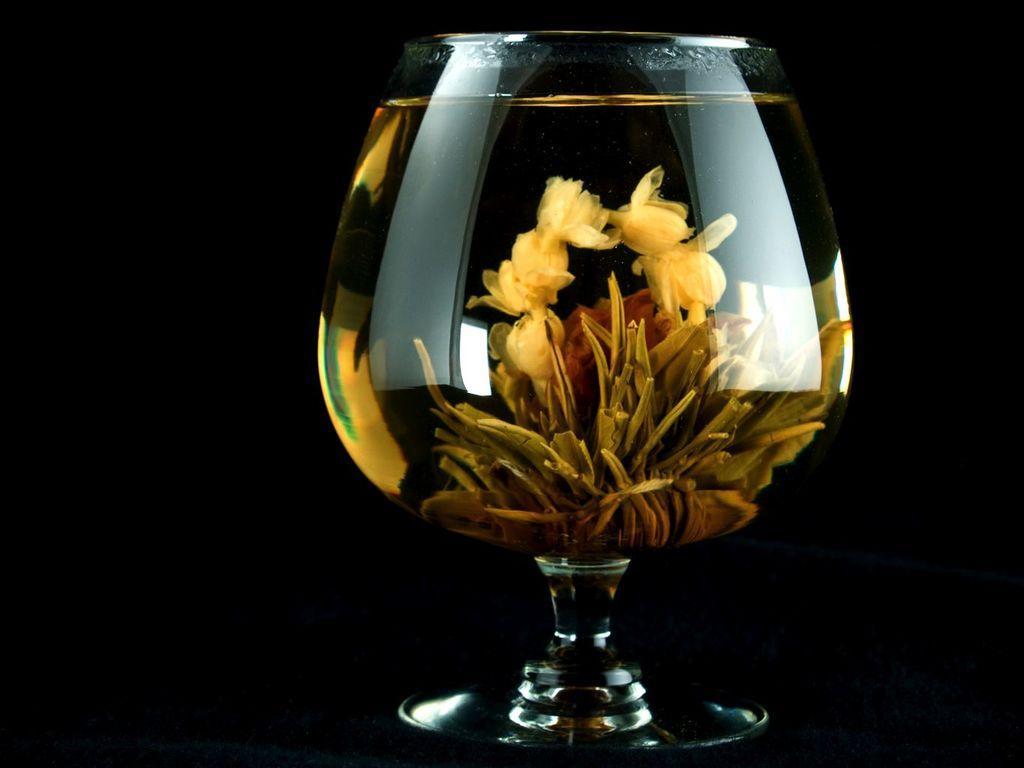In one or two sentences, can you explain what this image depicts? In this picture I can see a glass in front and I see few things in the glass which are of yellow and brown in color and I see that it is dark in the background. 